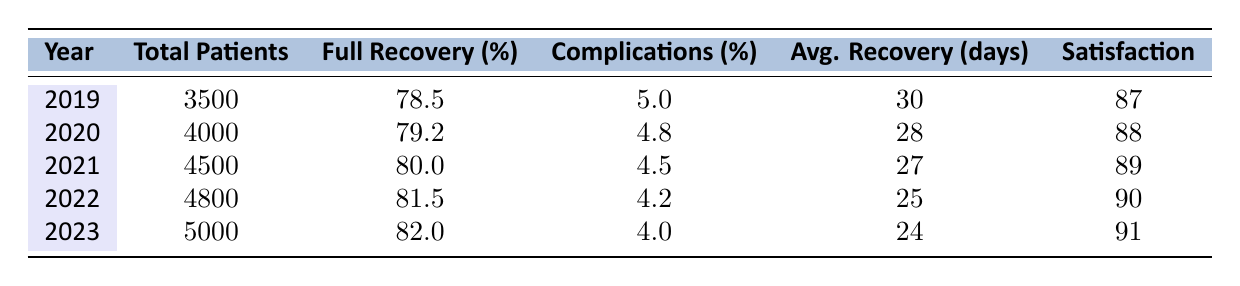What was the total number of patients in 2021? The table shows that the total number of patients in 2021 is listed directly in the column for "Total Patients." Referring to that row, the value is 4500.
Answer: 4500 What was the average recovery time in days in 2023? Referring to the column for "Avg. Recovery (days)" in the 2023 row of the table, the average recovery time is 24 days.
Answer: 24 What is the full recovery rate for 2022? The "Full Recovery (%)" column indicates that in 2022, the full recovery rate is 81.5%.
Answer: 81.5% How many total patients were there in 2019 and 2020 combined? The total patients for 2019 is 3500, and for 2020 it is 4000. Adding these two gives 3500 + 4000 = 7500.
Answer: 7500 What is the difference between the full recovery rates of 2021 and 2022? The full recovery rate for 2021 is 80.0% and for 2022 is 81.5%. The difference is calculated as 81.5 - 80.0 = 1.5%.
Answer: 1.5% In which year was the patient satisfaction score the highest? The patient satisfaction scores are listed in the last column. The highest score is 91 in 2023.
Answer: 2023 What was the percentage of complications in 2020? The complications percentage for 2020 is found in the "Complications (%)" column, which shows a value of 4.8%.
Answer: 4.8% If the average recovery time improved continuously, what was the increase in full recovery rate from 2019 to 2023? The full recovery rate for 2019 is 78.5% and for 2023 is 82.0%. The increase is calculated as 82.0 - 78.5 = 3.5%.
Answer: 3.5% Is the average recovery time decreasing over the years? Observing the "Avg. Recovery (days)" column, the values are 30, 28, 27, 25, and 24 from 2019 to 2023. Since all these values are decreasing, the answer is yes.
Answer: Yes What was the overall trend in patient satisfaction from 2019 to 2023? By looking at the "Satisfaction" scores from 2019 (87) to 2023 (91), we see an increase each year. Thus, the trend is upward.
Answer: Upward 